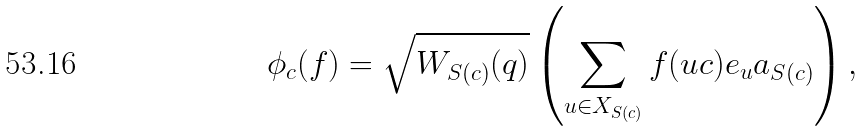<formula> <loc_0><loc_0><loc_500><loc_500>\phi _ { c } ( f ) = \sqrt { W _ { S ( c ) } ( q ) } \left ( \sum _ { u \in X _ { S ( c ) } } f ( u c ) e _ { u } a _ { S ( c ) } \right ) ,</formula> 